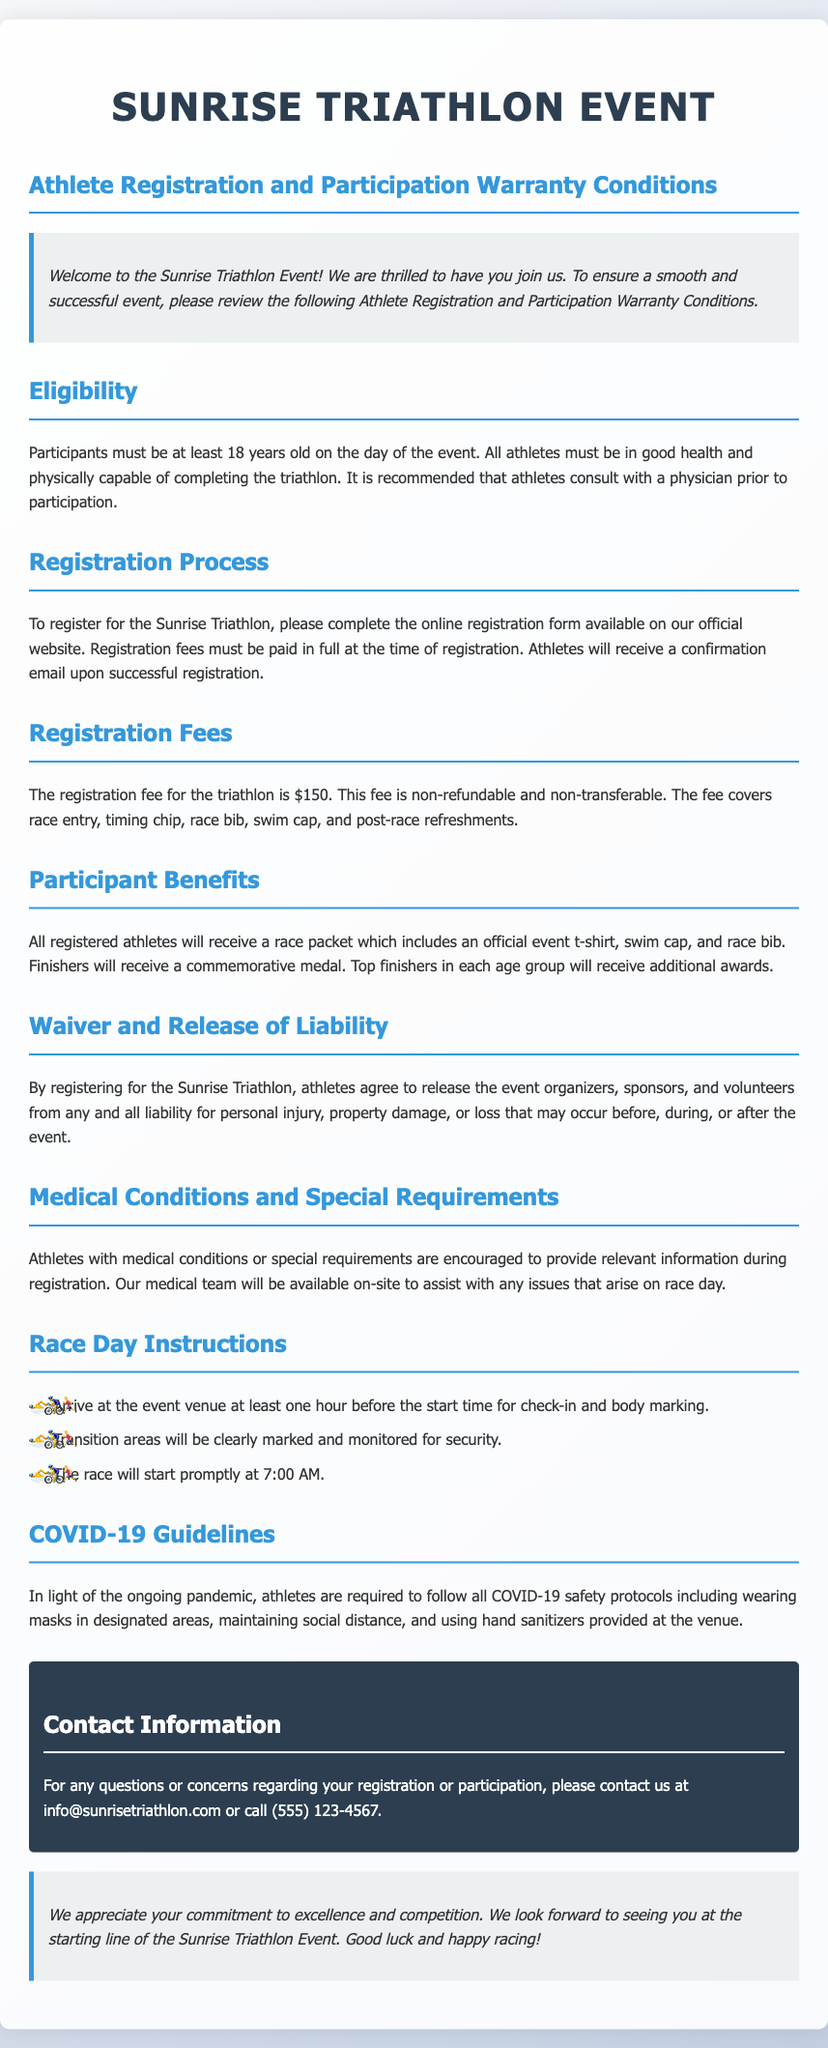What is the minimum age to participate? Participants must be at least 18 years old on the day of the event.
Answer: 18 years old What is the registration fee for the triathlon? The registration fee for the triathlon is stated clearly in the document.
Answer: $150 What do finishers receive? The document specifies what finishers will receive after completing the race.
Answer: Commemorative medal What should athletes do if they have medical conditions? The document advises what athletes with medical conditions should do during registration.
Answer: Provide relevant information What time does the race start? The starting time of the race is mentioned directly in the document.
Answer: 7:00 AM Why are athletes required to wear masks? The document discusses the safety protocols related to COVID-19.
Answer: COVID-19 safety protocols What items are included in the race packet? The contents of the race packet are listed in the document.
Answer: Official event t-shirt, swim cap, and race bib Is the registration fee refundable? The document indicates the nature of the registration fee regarding refunds.
Answer: Non-refundable How can participants contact the event organizers? The document provides contact information for participants.
Answer: info@sunrisetriathlon.com 